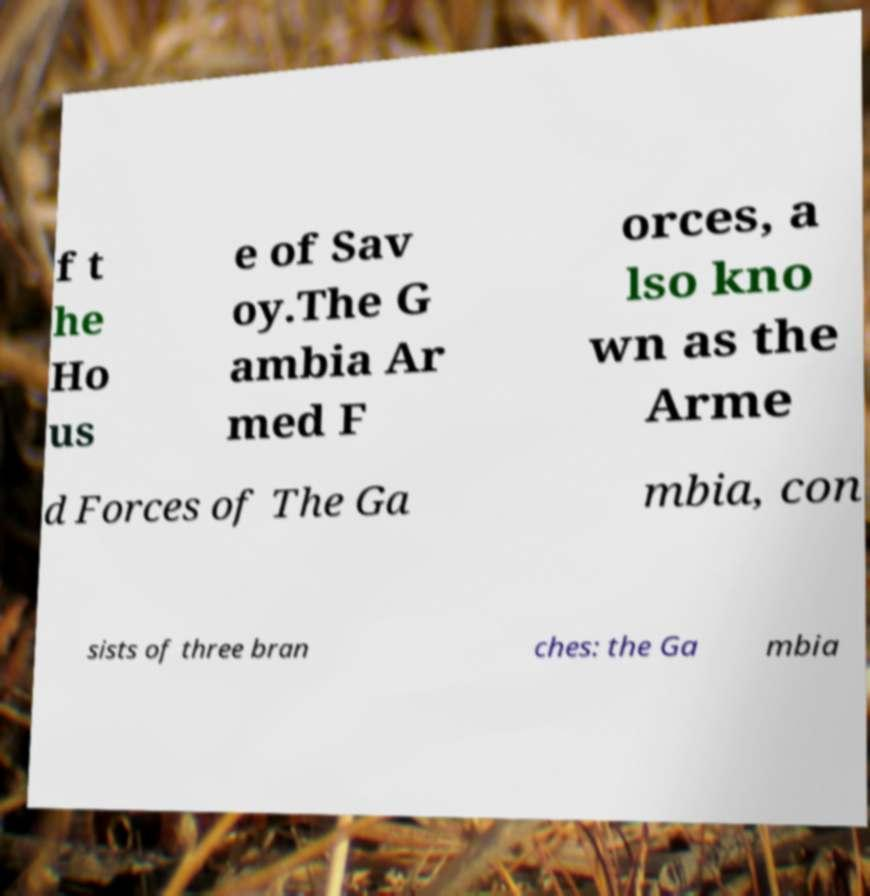Could you assist in decoding the text presented in this image and type it out clearly? f t he Ho us e of Sav oy.The G ambia Ar med F orces, a lso kno wn as the Arme d Forces of The Ga mbia, con sists of three bran ches: the Ga mbia 